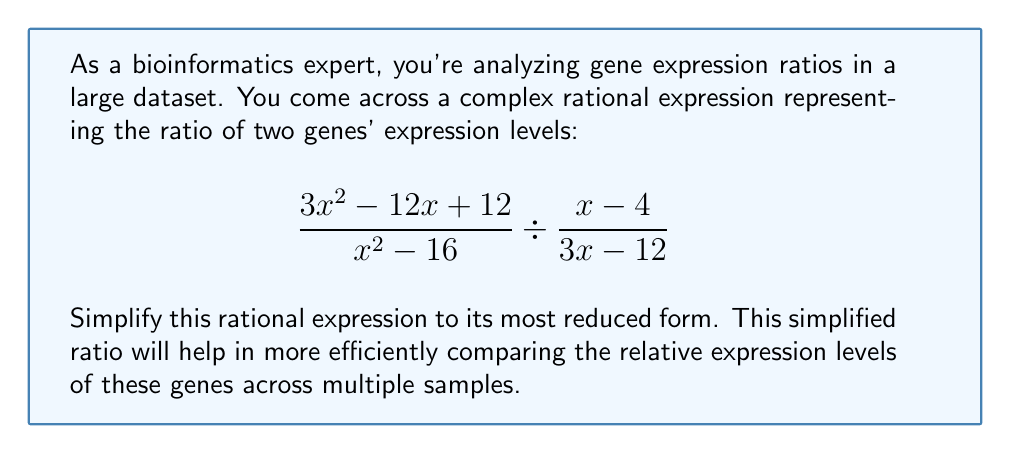Help me with this question. Let's simplify this rational expression step-by-step:

1) First, recall that dividing by a fraction is equivalent to multiplying by its reciprocal:

   $$\frac{3x^2 - 12x + 12}{x^2 - 16} \cdot \frac{3x - 12}{x - 4}$$

2) Now, let's factor the numerator and denominator of the first fraction:
   
   $$\frac{3(x^2 - 4x + 4)}{(x+4)(x-4)} \cdot \frac{3(x - 4)}{x - 4}$$

3) The numerator of the first fraction can be further factored:

   $$\frac{3(x-2)^2}{(x+4)(x-4)} \cdot \frac{3(x - 4)}{x - 4}$$

4) Now we can cancel $(x-4)$ from the denominator of the first fraction and the numerator of the second fraction:

   $$\frac{3(x-2)^2}{(x+4)} \cdot \frac{3}{1}$$

5) Multiply the numerators and denominators:

   $$\frac{9(x-2)^2}{x+4}$$

This is the most simplified form of the rational expression.
Answer: $$\frac{9(x-2)^2}{x+4}$$ 